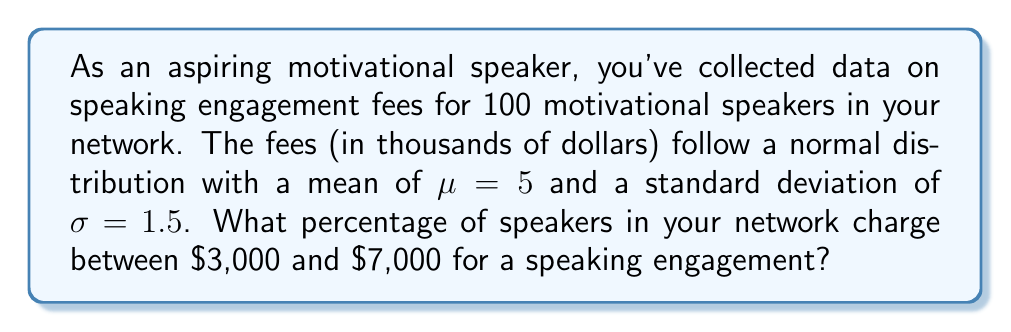Teach me how to tackle this problem. To solve this problem, we need to use the properties of the normal distribution and the concept of z-scores.

1) First, we need to convert the given dollar amounts to z-scores:

   For $3,000: z_1 = \frac{3 - 5}{1.5} = -1.33$
   For $7,000: z_2 = \frac{7 - 5}{1.5} = 1.33$

2) Now, we need to find the area under the standard normal curve between these two z-scores.

3) We can use the standard normal distribution table or a calculator to find the area between -1.33 and 1.33.

4) The area under the standard normal curve from -1.33 to 1.33 is approximately 0.8164.

5) This means that 81.64% of the data falls between these two z-scores.

6) Therefore, 81.64% of the speakers in your network charge between $3,000 and $7,000 for a speaking engagement.

The calculation can be represented mathematically as:

$$P(3000 < X < 7000) = P(-1.33 < Z < 1.33) = 0.8164$$

Where $X$ is the speaking fee and $Z$ is the standard normal variable.
Answer: 81.64% of speakers charge between $3,000 and $7,000 for a speaking engagement. 